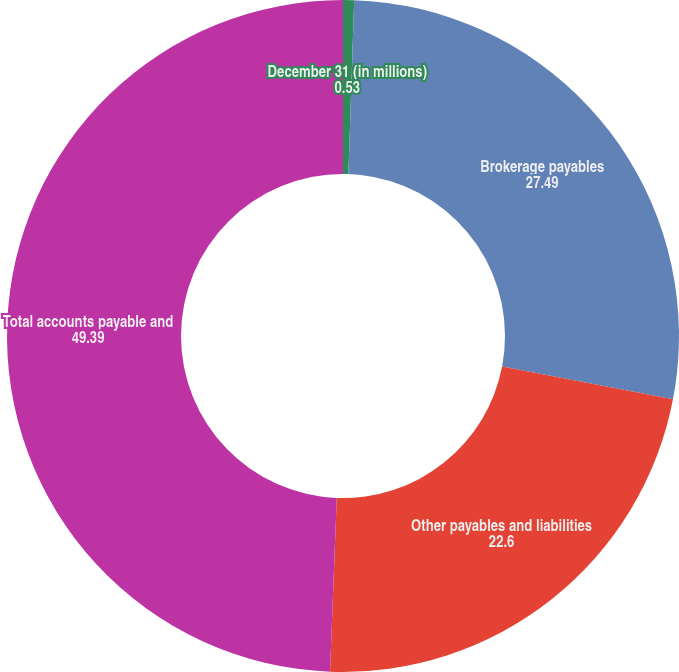<chart> <loc_0><loc_0><loc_500><loc_500><pie_chart><fcel>December 31 (in millions)<fcel>Brokerage payables<fcel>Other payables and liabilities<fcel>Total accounts payable and<nl><fcel>0.53%<fcel>27.49%<fcel>22.6%<fcel>49.39%<nl></chart> 